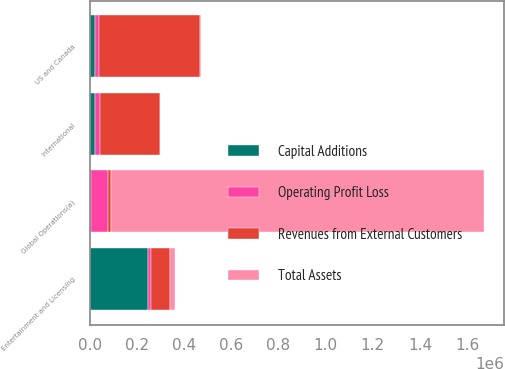<chart> <loc_0><loc_0><loc_500><loc_500><stacked_bar_chart><ecel><fcel>US and Canada<fcel>International<fcel>Entertainment and Licensing<fcel>Global Operations(a)<nl><fcel>Capital Additions<fcel>21789<fcel>21789<fcel>244685<fcel>5431<nl><fcel>Total Assets<fcel>5339<fcel>15<fcel>23144<fcel>1.58366e+06<nl><fcel>Revenues from External Customers<fcel>430707<fcel>255365<fcel>76868<fcel>12022<nl><fcel>Operating Profit Loss<fcel>14946<fcel>20434<fcel>16251<fcel>70794<nl></chart> 